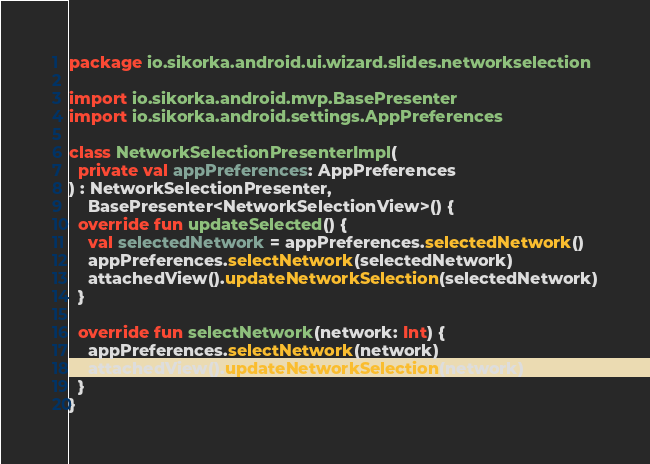<code> <loc_0><loc_0><loc_500><loc_500><_Kotlin_>package io.sikorka.android.ui.wizard.slides.networkselection

import io.sikorka.android.mvp.BasePresenter
import io.sikorka.android.settings.AppPreferences

class NetworkSelectionPresenterImpl(
  private val appPreferences: AppPreferences
) : NetworkSelectionPresenter,
    BasePresenter<NetworkSelectionView>() {
  override fun updateSelected() {
    val selectedNetwork = appPreferences.selectedNetwork()
    appPreferences.selectNetwork(selectedNetwork)
    attachedView().updateNetworkSelection(selectedNetwork)
  }

  override fun selectNetwork(network: Int) {
    appPreferences.selectNetwork(network)
    attachedView().updateNetworkSelection(network)
  }
}</code> 